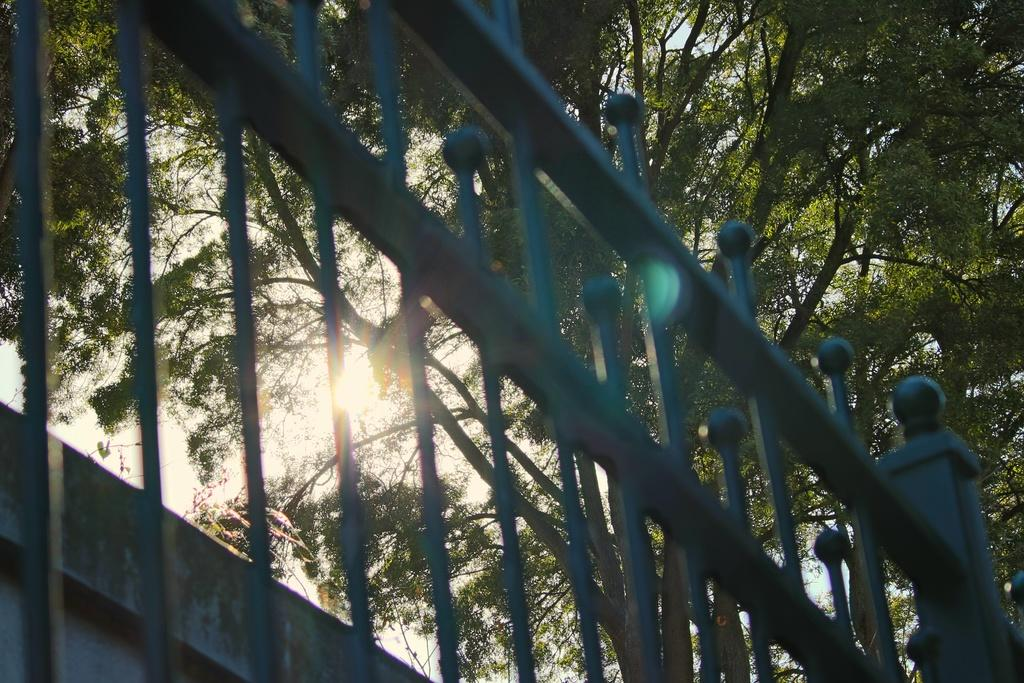What can be seen in the image that might provide support or safety? There are railings in the image. What type of natural elements can be seen in the background of the image? There are trees in the background of the image. What part of the natural environment is visible in the background of the image? The sky is visible in the background of the image. What type of apparatus is being used to measure the distance between the trees in the image? There is no apparatus present in the image for measuring distances. How many cents can be seen in the image? There are no cents visible in the image. Can you describe any romantic gestures taking place in the image? There is no indication of any romantic gestures or kisses in the image. 